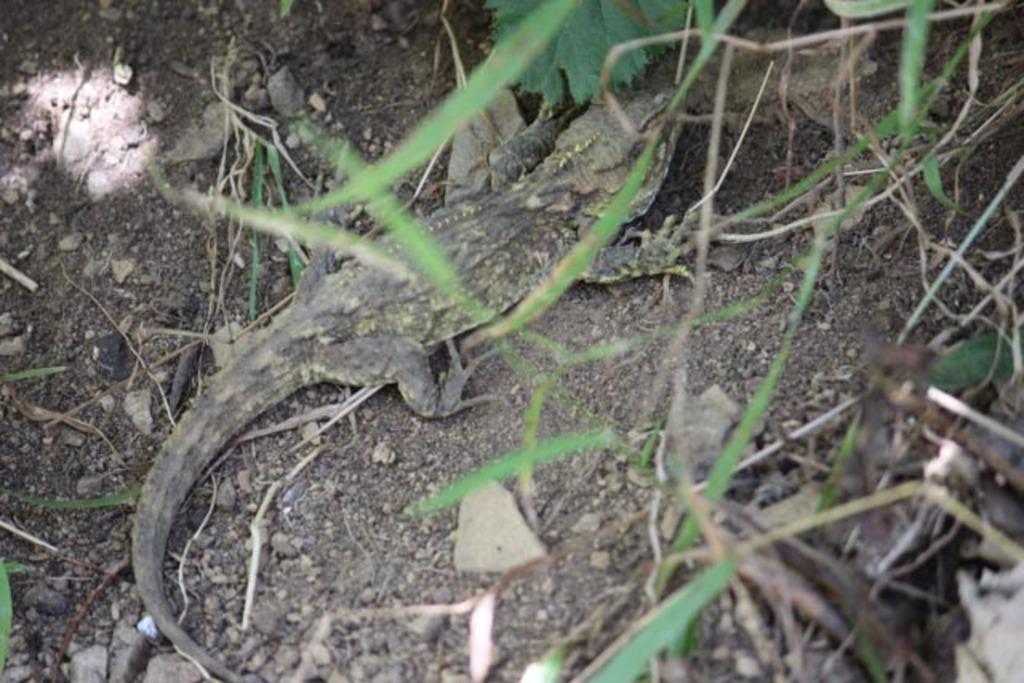Could you give a brief overview of what you see in this image? In the center of the image we can see a reptile is present on the ground. In the background of the image we can see the grass, stones. 